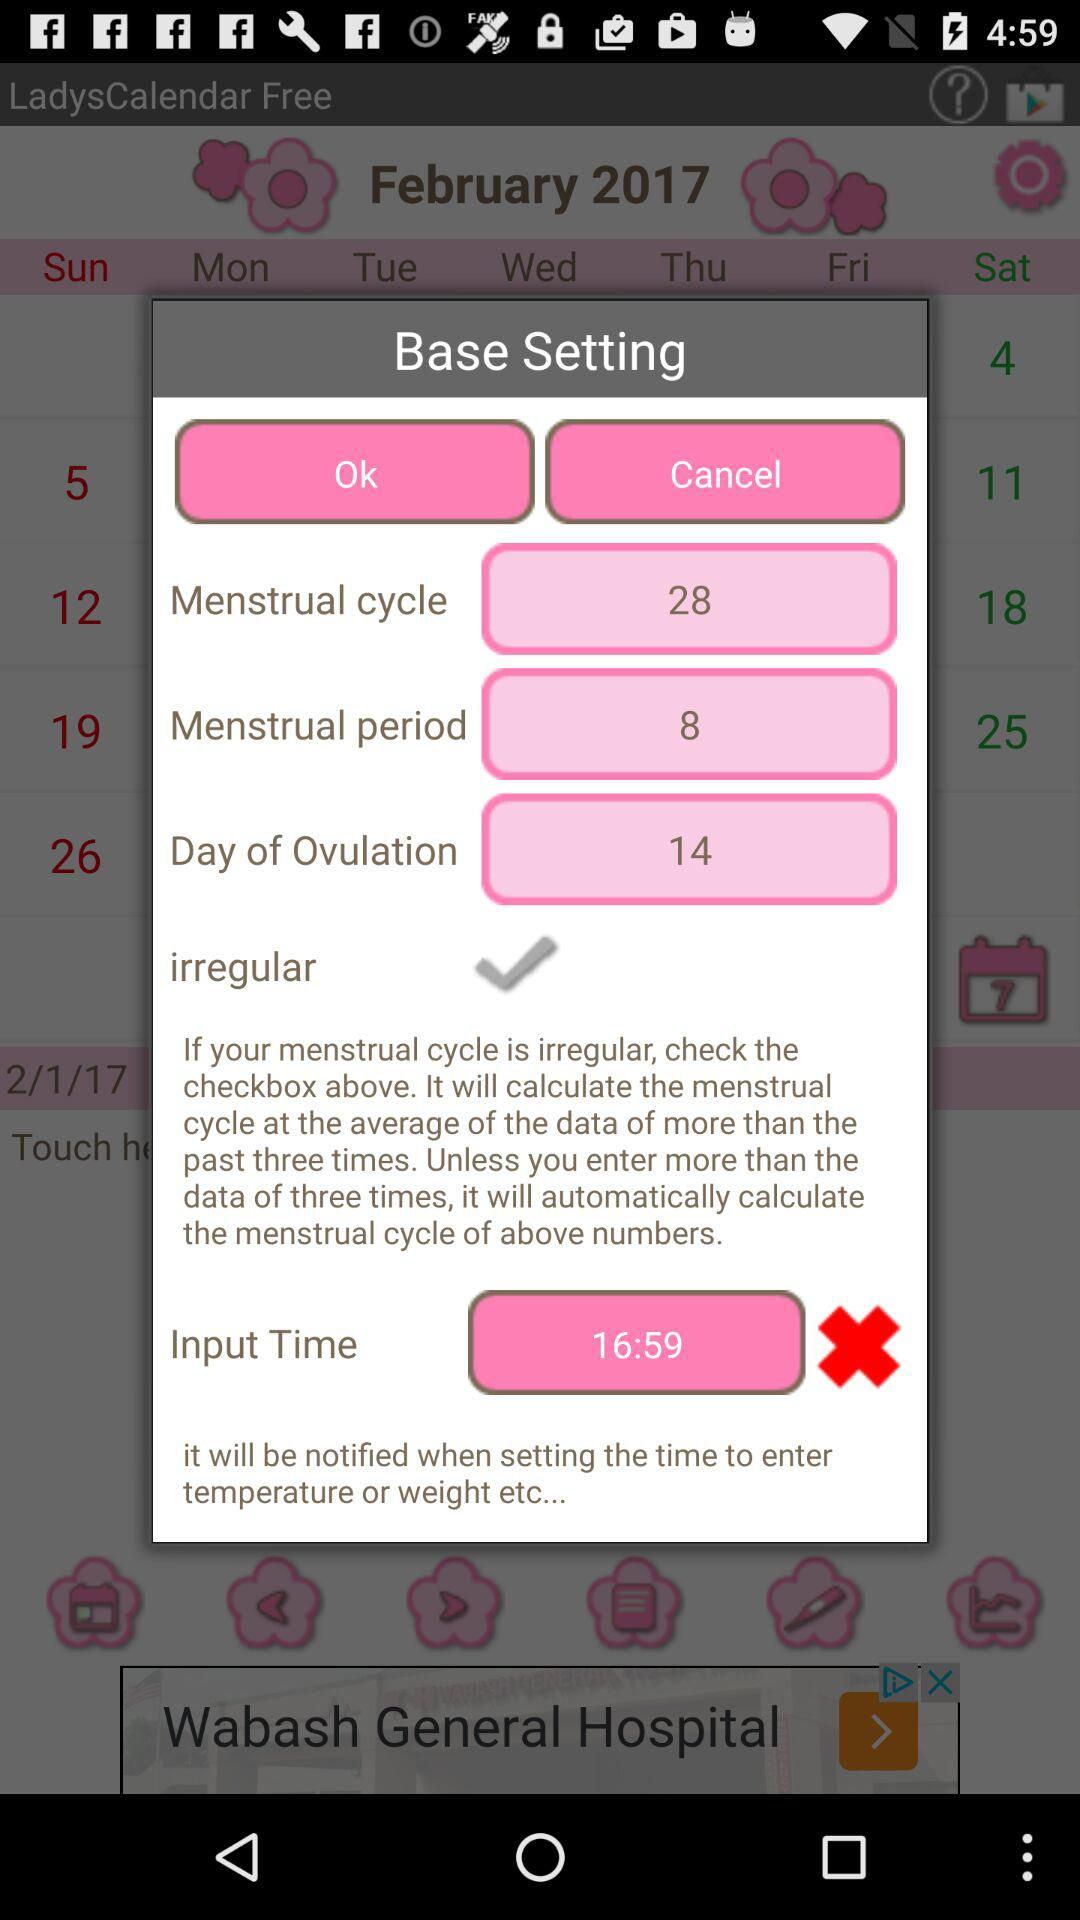What is the menstrual cycle duration? The menstrual cycle duration is 28 days. 